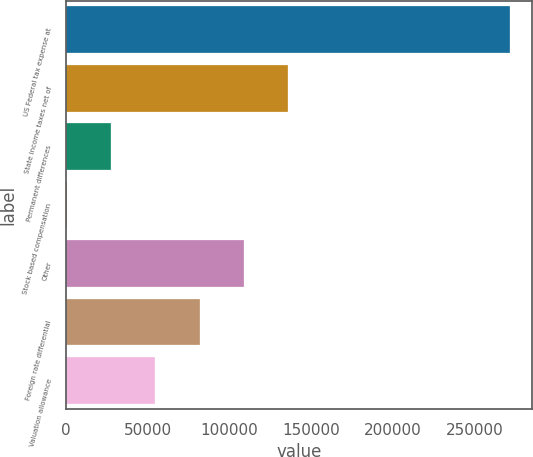Convert chart. <chart><loc_0><loc_0><loc_500><loc_500><bar_chart><fcel>US Federal tax expense at<fcel>State income taxes net of<fcel>Permanent differences<fcel>Stock based compensation<fcel>Other<fcel>Foreign rate differential<fcel>Valuation allowance<nl><fcel>271587<fcel>135978<fcel>27491.7<fcel>370<fcel>108857<fcel>81735.1<fcel>54613.4<nl></chart> 